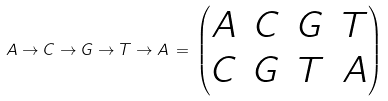<formula> <loc_0><loc_0><loc_500><loc_500>A \to C \to G \to T \to A \, = \, \begin{pmatrix} A & C & G & T \\ C & G & T & A \end{pmatrix}</formula> 